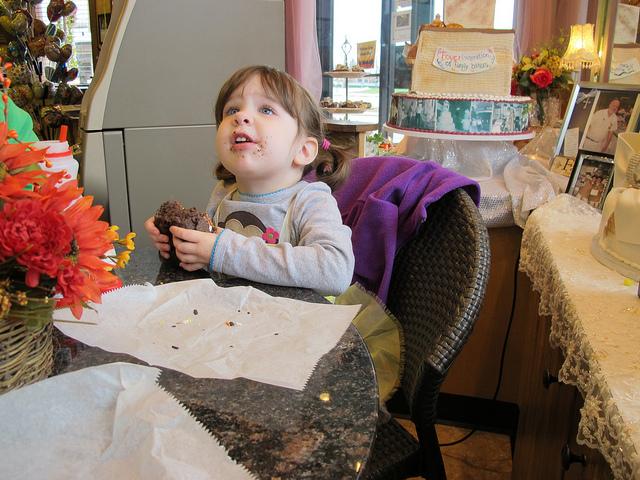Is the child over ten years old?
Concise answer only. No. What color is the jacket over the back of the chair?
Give a very brief answer. Purple. Is the child looking down?
Short answer required. No. What color is the wicker?
Answer briefly. Brown. 